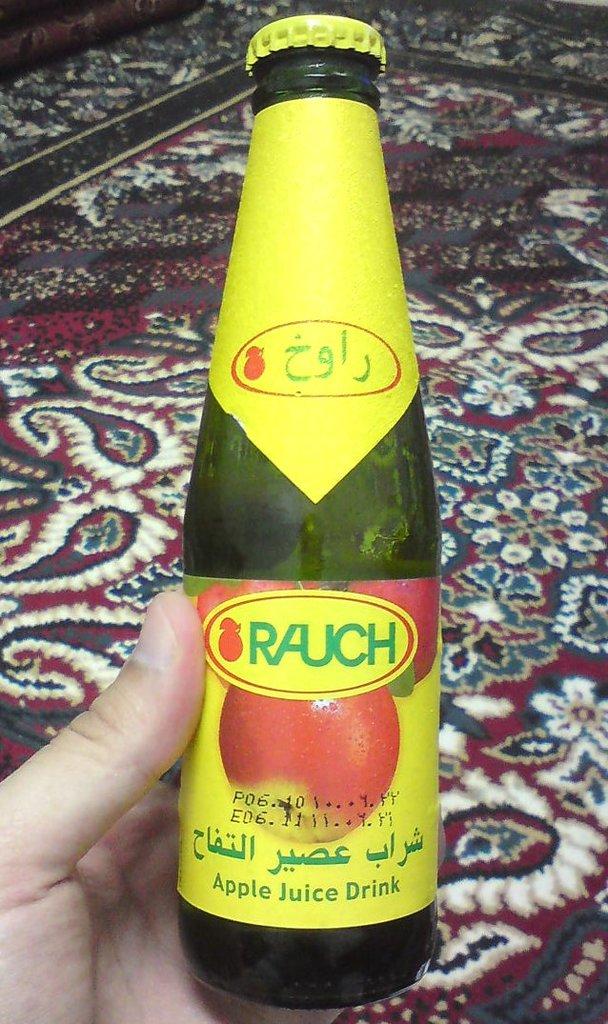What kind of drink is this?
Provide a short and direct response. Apple juice. What brand is the drink?
Your response must be concise. Rauch. 